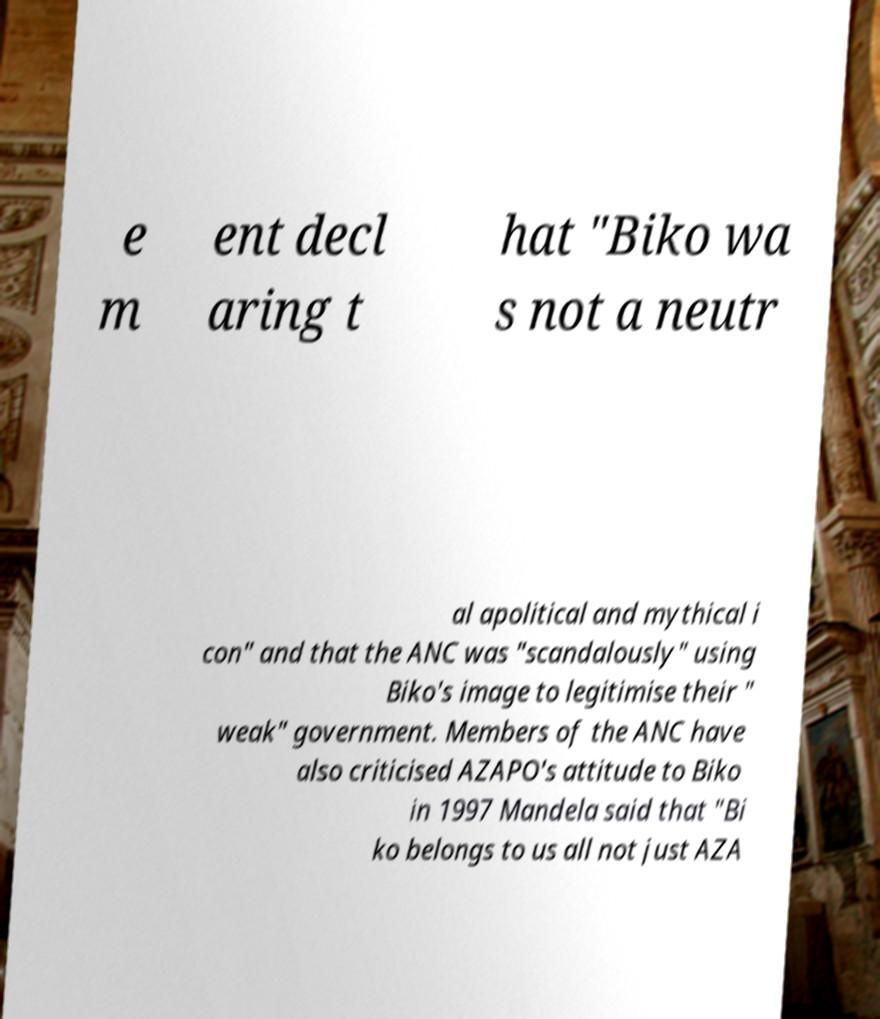Could you assist in decoding the text presented in this image and type it out clearly? e m ent decl aring t hat "Biko wa s not a neutr al apolitical and mythical i con" and that the ANC was "scandalously" using Biko's image to legitimise their " weak" government. Members of the ANC have also criticised AZAPO's attitude to Biko in 1997 Mandela said that "Bi ko belongs to us all not just AZA 